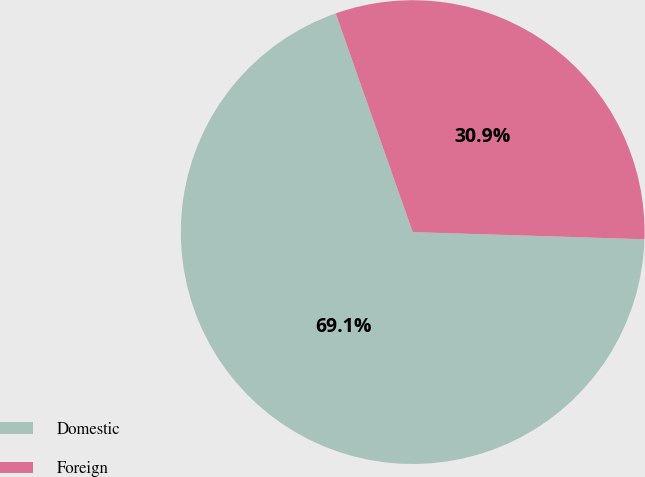Convert chart. <chart><loc_0><loc_0><loc_500><loc_500><pie_chart><fcel>Domestic<fcel>Foreign<nl><fcel>69.12%<fcel>30.88%<nl></chart> 